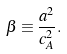Convert formula to latex. <formula><loc_0><loc_0><loc_500><loc_500>\beta \equiv \frac { a ^ { 2 } } { c _ { A } ^ { 2 } } .</formula> 